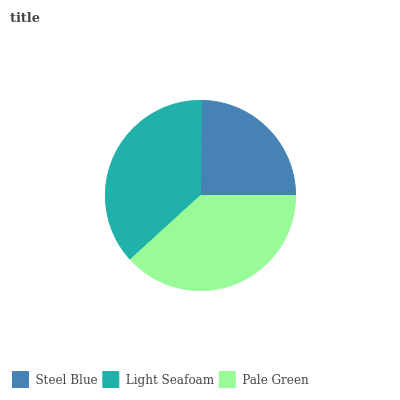Is Steel Blue the minimum?
Answer yes or no. Yes. Is Pale Green the maximum?
Answer yes or no. Yes. Is Light Seafoam the minimum?
Answer yes or no. No. Is Light Seafoam the maximum?
Answer yes or no. No. Is Light Seafoam greater than Steel Blue?
Answer yes or no. Yes. Is Steel Blue less than Light Seafoam?
Answer yes or no. Yes. Is Steel Blue greater than Light Seafoam?
Answer yes or no. No. Is Light Seafoam less than Steel Blue?
Answer yes or no. No. Is Light Seafoam the high median?
Answer yes or no. Yes. Is Light Seafoam the low median?
Answer yes or no. Yes. Is Steel Blue the high median?
Answer yes or no. No. Is Pale Green the low median?
Answer yes or no. No. 